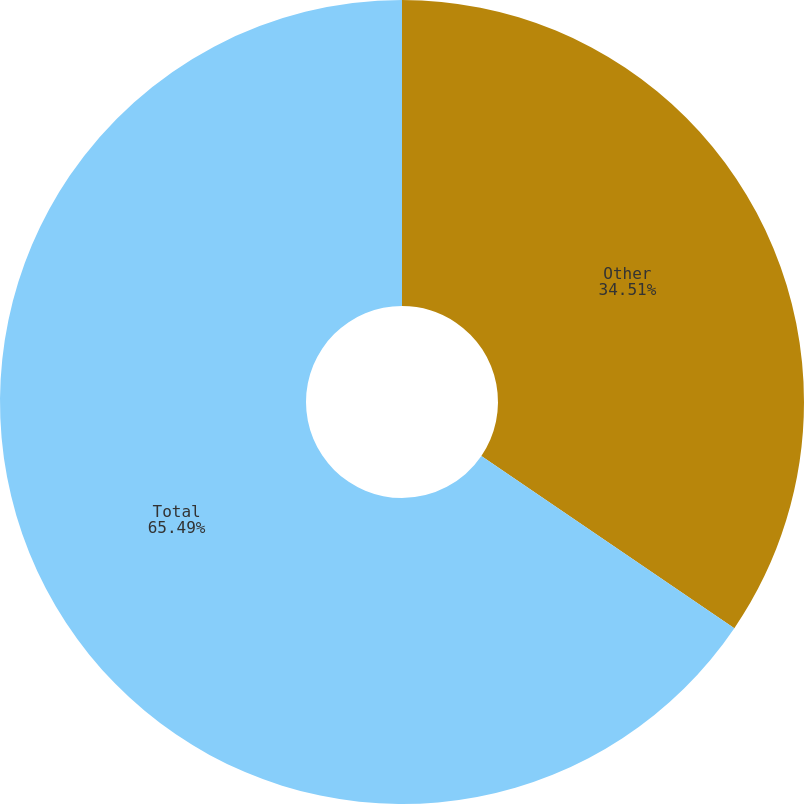<chart> <loc_0><loc_0><loc_500><loc_500><pie_chart><fcel>Other<fcel>Total<nl><fcel>34.51%<fcel>65.49%<nl></chart> 